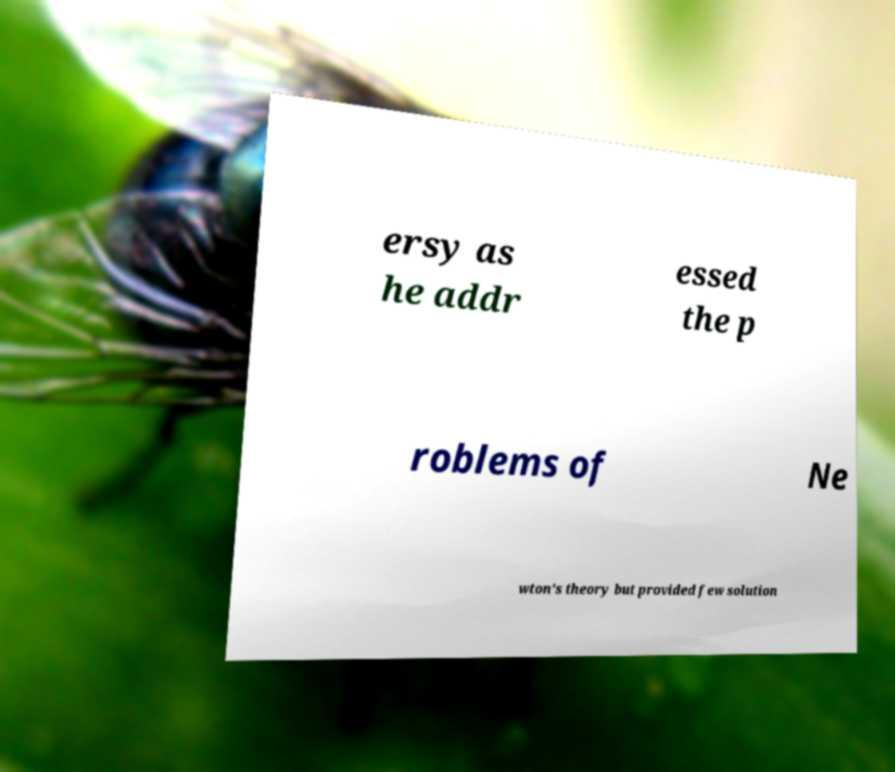For documentation purposes, I need the text within this image transcribed. Could you provide that? ersy as he addr essed the p roblems of Ne wton's theory but provided few solution 